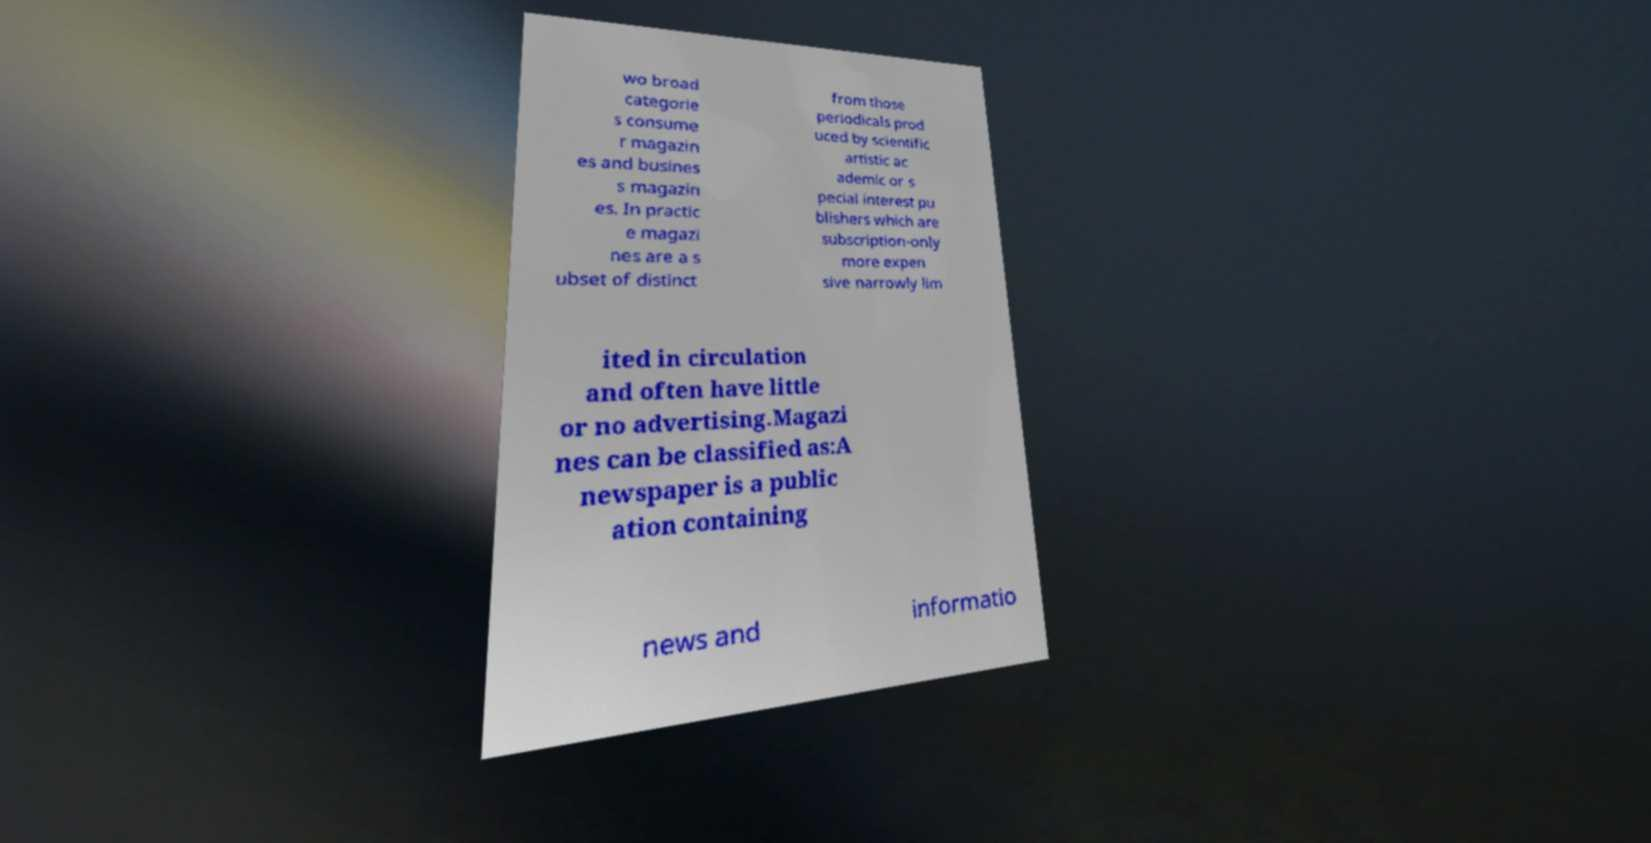Can you accurately transcribe the text from the provided image for me? wo broad categorie s consume r magazin es and busines s magazin es. In practic e magazi nes are a s ubset of distinct from those periodicals prod uced by scientific artistic ac ademic or s pecial interest pu blishers which are subscription-only more expen sive narrowly lim ited in circulation and often have little or no advertising.Magazi nes can be classified as:A newspaper is a public ation containing news and informatio 